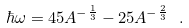Convert formula to latex. <formula><loc_0><loc_0><loc_500><loc_500>\hbar { \omega } = 4 5 A ^ { - \frac { 1 } { 3 } } - 2 5 A ^ { - \frac { 2 } { 3 } } \ .</formula> 